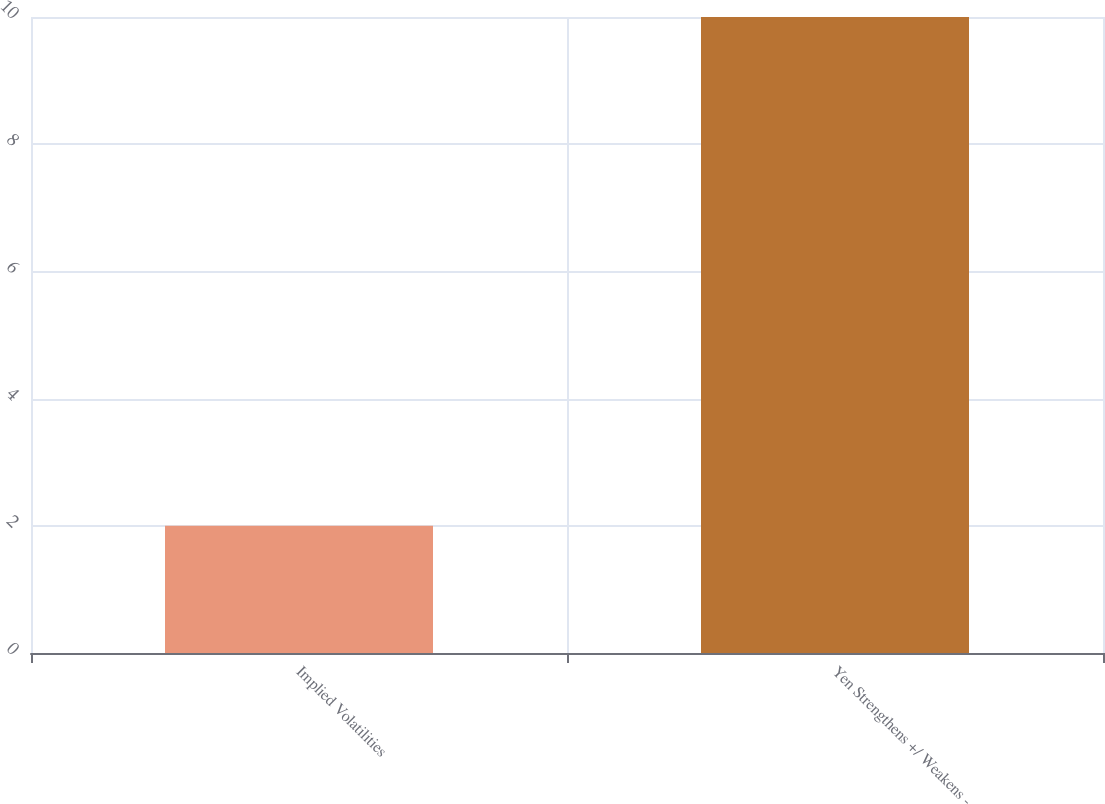<chart> <loc_0><loc_0><loc_500><loc_500><bar_chart><fcel>Implied Volatilities<fcel>Yen Strengthens +/ Weakens -<nl><fcel>2<fcel>10<nl></chart> 